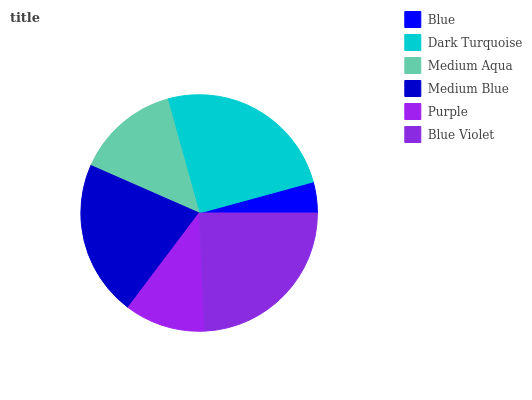Is Blue the minimum?
Answer yes or no. Yes. Is Dark Turquoise the maximum?
Answer yes or no. Yes. Is Medium Aqua the minimum?
Answer yes or no. No. Is Medium Aqua the maximum?
Answer yes or no. No. Is Dark Turquoise greater than Medium Aqua?
Answer yes or no. Yes. Is Medium Aqua less than Dark Turquoise?
Answer yes or no. Yes. Is Medium Aqua greater than Dark Turquoise?
Answer yes or no. No. Is Dark Turquoise less than Medium Aqua?
Answer yes or no. No. Is Medium Blue the high median?
Answer yes or no. Yes. Is Medium Aqua the low median?
Answer yes or no. Yes. Is Blue the high median?
Answer yes or no. No. Is Blue Violet the low median?
Answer yes or no. No. 